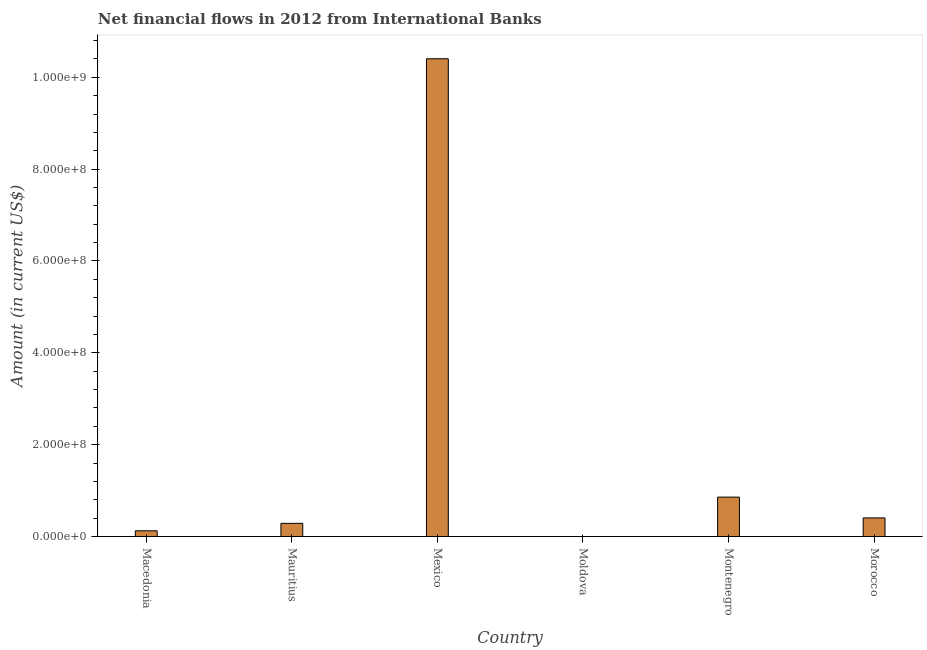What is the title of the graph?
Your answer should be very brief. Net financial flows in 2012 from International Banks. What is the net financial flows from ibrd in Montenegro?
Your response must be concise. 8.58e+07. Across all countries, what is the maximum net financial flows from ibrd?
Keep it short and to the point. 1.04e+09. What is the sum of the net financial flows from ibrd?
Ensure brevity in your answer.  1.21e+09. What is the difference between the net financial flows from ibrd in Mauritius and Mexico?
Your answer should be very brief. -1.01e+09. What is the average net financial flows from ibrd per country?
Ensure brevity in your answer.  2.01e+08. What is the median net financial flows from ibrd?
Your answer should be very brief. 3.45e+07. In how many countries, is the net financial flows from ibrd greater than 320000000 US$?
Your response must be concise. 1. What is the ratio of the net financial flows from ibrd in Macedonia to that in Morocco?
Ensure brevity in your answer.  0.31. Is the net financial flows from ibrd in Macedonia less than that in Montenegro?
Your answer should be compact. Yes. Is the difference between the net financial flows from ibrd in Mexico and Morocco greater than the difference between any two countries?
Keep it short and to the point. No. What is the difference between the highest and the second highest net financial flows from ibrd?
Keep it short and to the point. 9.55e+08. Is the sum of the net financial flows from ibrd in Macedonia and Montenegro greater than the maximum net financial flows from ibrd across all countries?
Keep it short and to the point. No. What is the difference between the highest and the lowest net financial flows from ibrd?
Provide a succinct answer. 1.04e+09. How many bars are there?
Offer a very short reply. 5. Are all the bars in the graph horizontal?
Your answer should be compact. No. What is the Amount (in current US$) of Macedonia?
Keep it short and to the point. 1.24e+07. What is the Amount (in current US$) of Mauritius?
Make the answer very short. 2.86e+07. What is the Amount (in current US$) in Mexico?
Your answer should be very brief. 1.04e+09. What is the Amount (in current US$) in Montenegro?
Your answer should be compact. 8.58e+07. What is the Amount (in current US$) of Morocco?
Provide a succinct answer. 4.05e+07. What is the difference between the Amount (in current US$) in Macedonia and Mauritius?
Offer a very short reply. -1.62e+07. What is the difference between the Amount (in current US$) in Macedonia and Mexico?
Ensure brevity in your answer.  -1.03e+09. What is the difference between the Amount (in current US$) in Macedonia and Montenegro?
Your answer should be very brief. -7.34e+07. What is the difference between the Amount (in current US$) in Macedonia and Morocco?
Provide a succinct answer. -2.80e+07. What is the difference between the Amount (in current US$) in Mauritius and Mexico?
Ensure brevity in your answer.  -1.01e+09. What is the difference between the Amount (in current US$) in Mauritius and Montenegro?
Provide a succinct answer. -5.72e+07. What is the difference between the Amount (in current US$) in Mauritius and Morocco?
Make the answer very short. -1.19e+07. What is the difference between the Amount (in current US$) in Mexico and Montenegro?
Give a very brief answer. 9.55e+08. What is the difference between the Amount (in current US$) in Mexico and Morocco?
Give a very brief answer. 1.00e+09. What is the difference between the Amount (in current US$) in Montenegro and Morocco?
Your answer should be very brief. 4.53e+07. What is the ratio of the Amount (in current US$) in Macedonia to that in Mauritius?
Your answer should be very brief. 0.43. What is the ratio of the Amount (in current US$) in Macedonia to that in Mexico?
Provide a succinct answer. 0.01. What is the ratio of the Amount (in current US$) in Macedonia to that in Montenegro?
Offer a terse response. 0.14. What is the ratio of the Amount (in current US$) in Macedonia to that in Morocco?
Your answer should be compact. 0.31. What is the ratio of the Amount (in current US$) in Mauritius to that in Mexico?
Ensure brevity in your answer.  0.03. What is the ratio of the Amount (in current US$) in Mauritius to that in Montenegro?
Offer a very short reply. 0.33. What is the ratio of the Amount (in current US$) in Mauritius to that in Morocco?
Offer a very short reply. 0.71. What is the ratio of the Amount (in current US$) in Mexico to that in Montenegro?
Offer a terse response. 12.13. What is the ratio of the Amount (in current US$) in Mexico to that in Morocco?
Provide a succinct answer. 25.7. What is the ratio of the Amount (in current US$) in Montenegro to that in Morocco?
Keep it short and to the point. 2.12. 